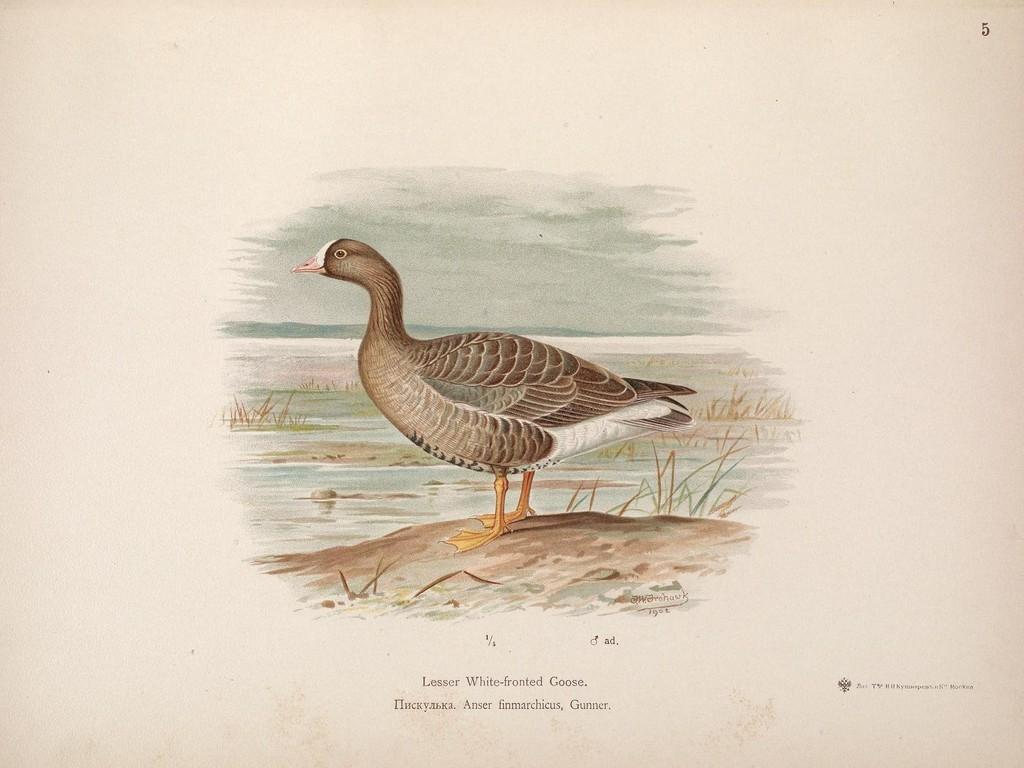Can you describe this image briefly? In this image I can see the bird and the bird is in brown, cream and white color. Background I can see the grass and I can see something is written on the image. 